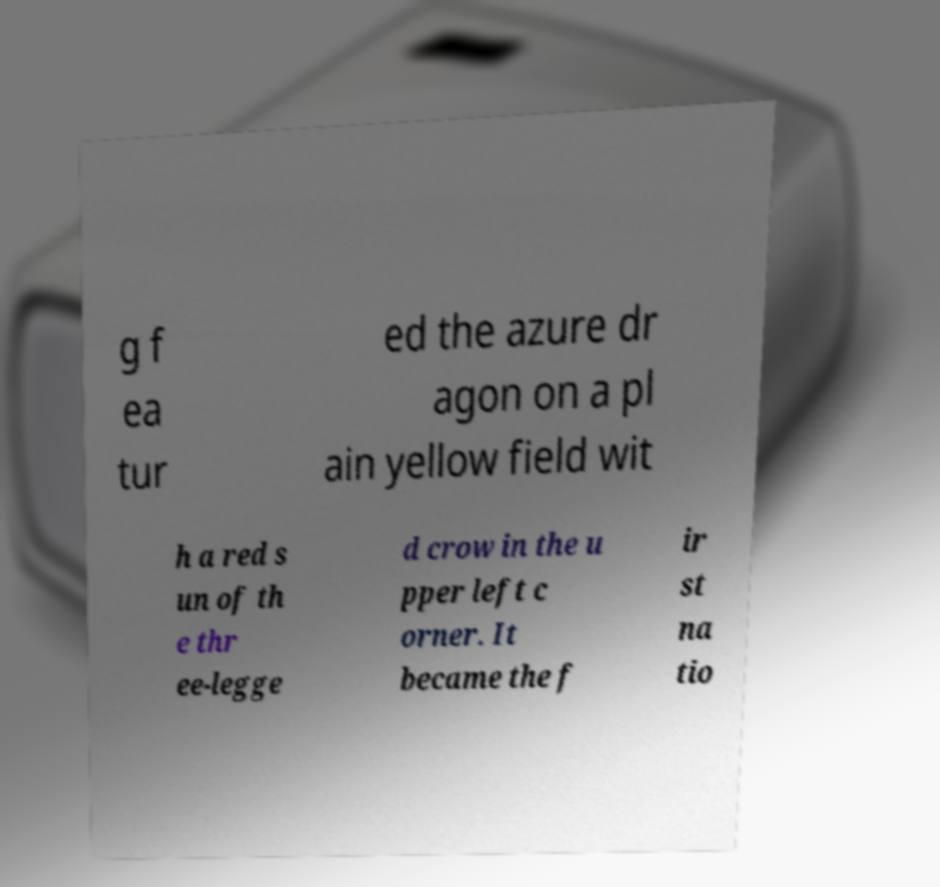Please identify and transcribe the text found in this image. g f ea tur ed the azure dr agon on a pl ain yellow field wit h a red s un of th e thr ee-legge d crow in the u pper left c orner. It became the f ir st na tio 